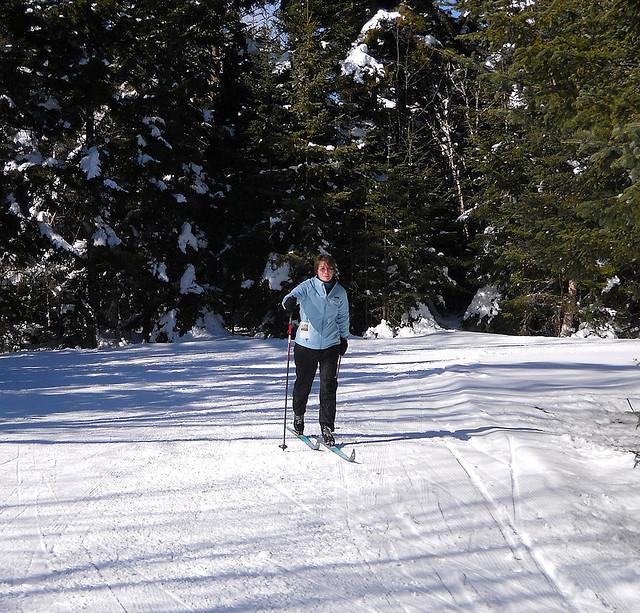Does she snowboard?
Answer briefly. No. What color is the man's jacket?
Be succinct. Blue. Why are there lines throughout the snow?
Concise answer only. Skid marks. How many skiers are there?
Write a very short answer. 1. Is the man walking?
Write a very short answer. No. Is the weather here nice?
Keep it brief. Yes. Is this girl standing up?
Quick response, please. Yes. Is it sunny?
Quick response, please. Yes. Is this person falling into the snow?
Answer briefly. No. How many people are skiing?
Be succinct. 1. Is the slope steep?
Concise answer only. No. Is the skiing uphill?
Answer briefly. No. What color is the person's jacket?
Be succinct. Blue. Does the woman have anything in her left hand?
Keep it brief. Yes. What activity is the person in the photo performing?
Quick response, please. Skiing. Is the woman sad to be alone?
Short answer required. No. 